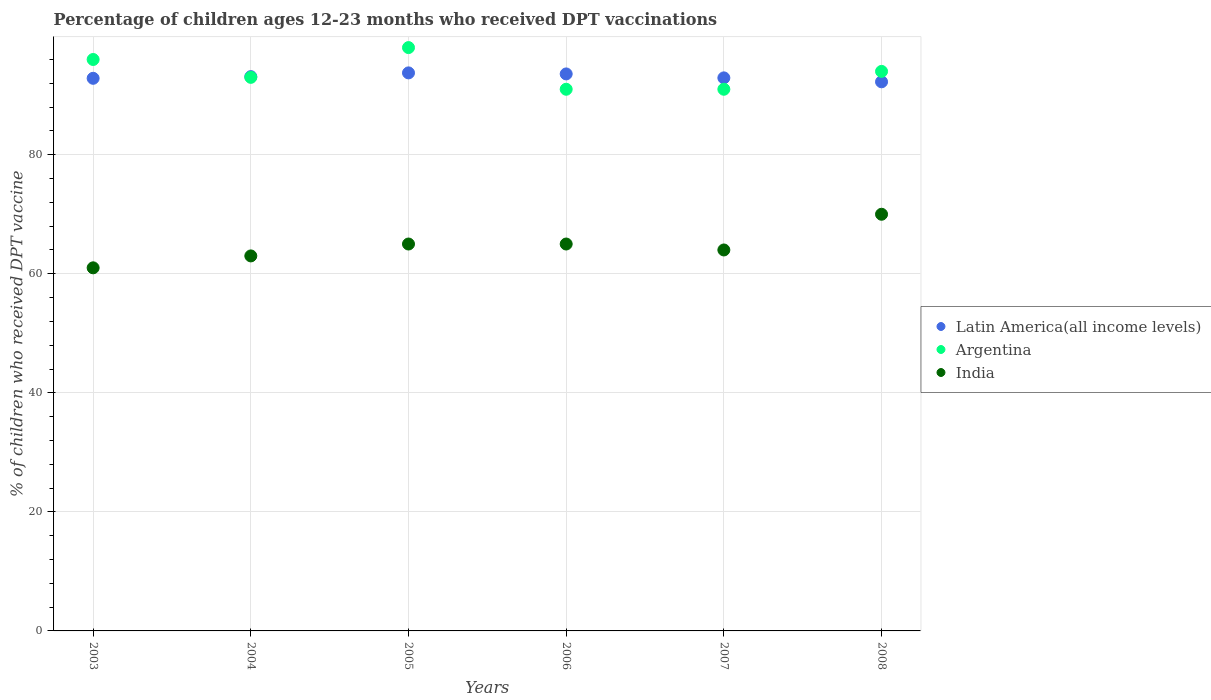What is the percentage of children who received DPT vaccination in India in 2005?
Provide a short and direct response. 65. Across all years, what is the maximum percentage of children who received DPT vaccination in Argentina?
Give a very brief answer. 98. Across all years, what is the minimum percentage of children who received DPT vaccination in Latin America(all income levels)?
Your answer should be compact. 92.25. What is the total percentage of children who received DPT vaccination in Argentina in the graph?
Your answer should be very brief. 563. What is the difference between the percentage of children who received DPT vaccination in Latin America(all income levels) in 2004 and that in 2008?
Your response must be concise. 0.87. What is the difference between the percentage of children who received DPT vaccination in India in 2006 and the percentage of children who received DPT vaccination in Argentina in 2003?
Ensure brevity in your answer.  -31. What is the average percentage of children who received DPT vaccination in Argentina per year?
Provide a short and direct response. 93.83. In the year 2007, what is the difference between the percentage of children who received DPT vaccination in Argentina and percentage of children who received DPT vaccination in Latin America(all income levels)?
Give a very brief answer. -1.91. In how many years, is the percentage of children who received DPT vaccination in India greater than 52 %?
Give a very brief answer. 6. What is the ratio of the percentage of children who received DPT vaccination in Latin America(all income levels) in 2003 to that in 2006?
Your answer should be compact. 0.99. Is the percentage of children who received DPT vaccination in Argentina in 2006 less than that in 2007?
Give a very brief answer. No. What is the difference between the highest and the second highest percentage of children who received DPT vaccination in Latin America(all income levels)?
Ensure brevity in your answer.  0.18. What is the difference between the highest and the lowest percentage of children who received DPT vaccination in Latin America(all income levels)?
Make the answer very short. 1.5. Is it the case that in every year, the sum of the percentage of children who received DPT vaccination in India and percentage of children who received DPT vaccination in Argentina  is greater than the percentage of children who received DPT vaccination in Latin America(all income levels)?
Keep it short and to the point. Yes. Does the percentage of children who received DPT vaccination in Argentina monotonically increase over the years?
Offer a terse response. No. Is the percentage of children who received DPT vaccination in India strictly greater than the percentage of children who received DPT vaccination in Argentina over the years?
Your answer should be compact. No. How many dotlines are there?
Provide a short and direct response. 3. How many years are there in the graph?
Your answer should be compact. 6. Are the values on the major ticks of Y-axis written in scientific E-notation?
Your response must be concise. No. Does the graph contain any zero values?
Give a very brief answer. No. Does the graph contain grids?
Your answer should be compact. Yes. Where does the legend appear in the graph?
Ensure brevity in your answer.  Center right. How are the legend labels stacked?
Make the answer very short. Vertical. What is the title of the graph?
Offer a terse response. Percentage of children ages 12-23 months who received DPT vaccinations. What is the label or title of the X-axis?
Your response must be concise. Years. What is the label or title of the Y-axis?
Keep it short and to the point. % of children who received DPT vaccine. What is the % of children who received DPT vaccine in Latin America(all income levels) in 2003?
Your answer should be very brief. 92.84. What is the % of children who received DPT vaccine of Argentina in 2003?
Keep it short and to the point. 96. What is the % of children who received DPT vaccine in Latin America(all income levels) in 2004?
Give a very brief answer. 93.12. What is the % of children who received DPT vaccine of Argentina in 2004?
Offer a very short reply. 93. What is the % of children who received DPT vaccine in Latin America(all income levels) in 2005?
Make the answer very short. 93.75. What is the % of children who received DPT vaccine in Argentina in 2005?
Your answer should be compact. 98. What is the % of children who received DPT vaccine in Latin America(all income levels) in 2006?
Offer a very short reply. 93.57. What is the % of children who received DPT vaccine of Argentina in 2006?
Make the answer very short. 91. What is the % of children who received DPT vaccine of India in 2006?
Provide a short and direct response. 65. What is the % of children who received DPT vaccine of Latin America(all income levels) in 2007?
Ensure brevity in your answer.  92.91. What is the % of children who received DPT vaccine in Argentina in 2007?
Provide a succinct answer. 91. What is the % of children who received DPT vaccine in Latin America(all income levels) in 2008?
Your response must be concise. 92.25. What is the % of children who received DPT vaccine of Argentina in 2008?
Your answer should be very brief. 94. What is the % of children who received DPT vaccine in India in 2008?
Offer a terse response. 70. Across all years, what is the maximum % of children who received DPT vaccine in Latin America(all income levels)?
Provide a succinct answer. 93.75. Across all years, what is the maximum % of children who received DPT vaccine in Argentina?
Your response must be concise. 98. Across all years, what is the minimum % of children who received DPT vaccine of Latin America(all income levels)?
Offer a terse response. 92.25. Across all years, what is the minimum % of children who received DPT vaccine of Argentina?
Keep it short and to the point. 91. Across all years, what is the minimum % of children who received DPT vaccine in India?
Keep it short and to the point. 61. What is the total % of children who received DPT vaccine in Latin America(all income levels) in the graph?
Make the answer very short. 558.45. What is the total % of children who received DPT vaccine in Argentina in the graph?
Ensure brevity in your answer.  563. What is the total % of children who received DPT vaccine in India in the graph?
Make the answer very short. 388. What is the difference between the % of children who received DPT vaccine in Latin America(all income levels) in 2003 and that in 2004?
Your response must be concise. -0.28. What is the difference between the % of children who received DPT vaccine in Latin America(all income levels) in 2003 and that in 2005?
Give a very brief answer. -0.91. What is the difference between the % of children who received DPT vaccine in Argentina in 2003 and that in 2005?
Your answer should be very brief. -2. What is the difference between the % of children who received DPT vaccine in Latin America(all income levels) in 2003 and that in 2006?
Provide a short and direct response. -0.74. What is the difference between the % of children who received DPT vaccine in Argentina in 2003 and that in 2006?
Give a very brief answer. 5. What is the difference between the % of children who received DPT vaccine in Latin America(all income levels) in 2003 and that in 2007?
Make the answer very short. -0.07. What is the difference between the % of children who received DPT vaccine of Argentina in 2003 and that in 2007?
Ensure brevity in your answer.  5. What is the difference between the % of children who received DPT vaccine of India in 2003 and that in 2007?
Your answer should be very brief. -3. What is the difference between the % of children who received DPT vaccine of Latin America(all income levels) in 2003 and that in 2008?
Offer a very short reply. 0.59. What is the difference between the % of children who received DPT vaccine of Latin America(all income levels) in 2004 and that in 2005?
Keep it short and to the point. -0.63. What is the difference between the % of children who received DPT vaccine of Argentina in 2004 and that in 2005?
Ensure brevity in your answer.  -5. What is the difference between the % of children who received DPT vaccine of India in 2004 and that in 2005?
Your answer should be very brief. -2. What is the difference between the % of children who received DPT vaccine of Latin America(all income levels) in 2004 and that in 2006?
Ensure brevity in your answer.  -0.45. What is the difference between the % of children who received DPT vaccine of Latin America(all income levels) in 2004 and that in 2007?
Ensure brevity in your answer.  0.21. What is the difference between the % of children who received DPT vaccine in Argentina in 2004 and that in 2007?
Your answer should be very brief. 2. What is the difference between the % of children who received DPT vaccine of India in 2004 and that in 2007?
Give a very brief answer. -1. What is the difference between the % of children who received DPT vaccine of Latin America(all income levels) in 2004 and that in 2008?
Ensure brevity in your answer.  0.87. What is the difference between the % of children who received DPT vaccine in Latin America(all income levels) in 2005 and that in 2006?
Make the answer very short. 0.18. What is the difference between the % of children who received DPT vaccine in India in 2005 and that in 2006?
Keep it short and to the point. 0. What is the difference between the % of children who received DPT vaccine in Latin America(all income levels) in 2005 and that in 2007?
Ensure brevity in your answer.  0.84. What is the difference between the % of children who received DPT vaccine of Argentina in 2005 and that in 2007?
Keep it short and to the point. 7. What is the difference between the % of children who received DPT vaccine of Latin America(all income levels) in 2005 and that in 2008?
Your answer should be compact. 1.5. What is the difference between the % of children who received DPT vaccine in Argentina in 2005 and that in 2008?
Your answer should be compact. 4. What is the difference between the % of children who received DPT vaccine of India in 2005 and that in 2008?
Provide a succinct answer. -5. What is the difference between the % of children who received DPT vaccine of Latin America(all income levels) in 2006 and that in 2007?
Give a very brief answer. 0.66. What is the difference between the % of children who received DPT vaccine of Argentina in 2006 and that in 2007?
Provide a succinct answer. 0. What is the difference between the % of children who received DPT vaccine in Latin America(all income levels) in 2006 and that in 2008?
Give a very brief answer. 1.32. What is the difference between the % of children who received DPT vaccine in India in 2006 and that in 2008?
Ensure brevity in your answer.  -5. What is the difference between the % of children who received DPT vaccine of Latin America(all income levels) in 2007 and that in 2008?
Keep it short and to the point. 0.66. What is the difference between the % of children who received DPT vaccine of Latin America(all income levels) in 2003 and the % of children who received DPT vaccine of Argentina in 2004?
Provide a succinct answer. -0.16. What is the difference between the % of children who received DPT vaccine of Latin America(all income levels) in 2003 and the % of children who received DPT vaccine of India in 2004?
Provide a succinct answer. 29.84. What is the difference between the % of children who received DPT vaccine of Argentina in 2003 and the % of children who received DPT vaccine of India in 2004?
Offer a terse response. 33. What is the difference between the % of children who received DPT vaccine in Latin America(all income levels) in 2003 and the % of children who received DPT vaccine in Argentina in 2005?
Your answer should be very brief. -5.16. What is the difference between the % of children who received DPT vaccine of Latin America(all income levels) in 2003 and the % of children who received DPT vaccine of India in 2005?
Provide a succinct answer. 27.84. What is the difference between the % of children who received DPT vaccine in Latin America(all income levels) in 2003 and the % of children who received DPT vaccine in Argentina in 2006?
Your answer should be compact. 1.84. What is the difference between the % of children who received DPT vaccine in Latin America(all income levels) in 2003 and the % of children who received DPT vaccine in India in 2006?
Offer a very short reply. 27.84. What is the difference between the % of children who received DPT vaccine of Latin America(all income levels) in 2003 and the % of children who received DPT vaccine of Argentina in 2007?
Make the answer very short. 1.84. What is the difference between the % of children who received DPT vaccine in Latin America(all income levels) in 2003 and the % of children who received DPT vaccine in India in 2007?
Your answer should be very brief. 28.84. What is the difference between the % of children who received DPT vaccine in Latin America(all income levels) in 2003 and the % of children who received DPT vaccine in Argentina in 2008?
Ensure brevity in your answer.  -1.16. What is the difference between the % of children who received DPT vaccine of Latin America(all income levels) in 2003 and the % of children who received DPT vaccine of India in 2008?
Your answer should be compact. 22.84. What is the difference between the % of children who received DPT vaccine of Argentina in 2003 and the % of children who received DPT vaccine of India in 2008?
Give a very brief answer. 26. What is the difference between the % of children who received DPT vaccine in Latin America(all income levels) in 2004 and the % of children who received DPT vaccine in Argentina in 2005?
Give a very brief answer. -4.88. What is the difference between the % of children who received DPT vaccine of Latin America(all income levels) in 2004 and the % of children who received DPT vaccine of India in 2005?
Your answer should be compact. 28.12. What is the difference between the % of children who received DPT vaccine of Argentina in 2004 and the % of children who received DPT vaccine of India in 2005?
Your answer should be compact. 28. What is the difference between the % of children who received DPT vaccine in Latin America(all income levels) in 2004 and the % of children who received DPT vaccine in Argentina in 2006?
Provide a succinct answer. 2.12. What is the difference between the % of children who received DPT vaccine of Latin America(all income levels) in 2004 and the % of children who received DPT vaccine of India in 2006?
Make the answer very short. 28.12. What is the difference between the % of children who received DPT vaccine of Latin America(all income levels) in 2004 and the % of children who received DPT vaccine of Argentina in 2007?
Offer a very short reply. 2.12. What is the difference between the % of children who received DPT vaccine in Latin America(all income levels) in 2004 and the % of children who received DPT vaccine in India in 2007?
Provide a short and direct response. 29.12. What is the difference between the % of children who received DPT vaccine in Argentina in 2004 and the % of children who received DPT vaccine in India in 2007?
Offer a terse response. 29. What is the difference between the % of children who received DPT vaccine in Latin America(all income levels) in 2004 and the % of children who received DPT vaccine in Argentina in 2008?
Offer a terse response. -0.88. What is the difference between the % of children who received DPT vaccine of Latin America(all income levels) in 2004 and the % of children who received DPT vaccine of India in 2008?
Your answer should be compact. 23.12. What is the difference between the % of children who received DPT vaccine of Latin America(all income levels) in 2005 and the % of children who received DPT vaccine of Argentina in 2006?
Ensure brevity in your answer.  2.75. What is the difference between the % of children who received DPT vaccine in Latin America(all income levels) in 2005 and the % of children who received DPT vaccine in India in 2006?
Provide a short and direct response. 28.75. What is the difference between the % of children who received DPT vaccine in Argentina in 2005 and the % of children who received DPT vaccine in India in 2006?
Keep it short and to the point. 33. What is the difference between the % of children who received DPT vaccine of Latin America(all income levels) in 2005 and the % of children who received DPT vaccine of Argentina in 2007?
Your response must be concise. 2.75. What is the difference between the % of children who received DPT vaccine in Latin America(all income levels) in 2005 and the % of children who received DPT vaccine in India in 2007?
Give a very brief answer. 29.75. What is the difference between the % of children who received DPT vaccine of Argentina in 2005 and the % of children who received DPT vaccine of India in 2007?
Ensure brevity in your answer.  34. What is the difference between the % of children who received DPT vaccine of Latin America(all income levels) in 2005 and the % of children who received DPT vaccine of Argentina in 2008?
Offer a terse response. -0.25. What is the difference between the % of children who received DPT vaccine in Latin America(all income levels) in 2005 and the % of children who received DPT vaccine in India in 2008?
Make the answer very short. 23.75. What is the difference between the % of children who received DPT vaccine of Latin America(all income levels) in 2006 and the % of children who received DPT vaccine of Argentina in 2007?
Make the answer very short. 2.57. What is the difference between the % of children who received DPT vaccine in Latin America(all income levels) in 2006 and the % of children who received DPT vaccine in India in 2007?
Provide a succinct answer. 29.57. What is the difference between the % of children who received DPT vaccine of Latin America(all income levels) in 2006 and the % of children who received DPT vaccine of Argentina in 2008?
Give a very brief answer. -0.43. What is the difference between the % of children who received DPT vaccine of Latin America(all income levels) in 2006 and the % of children who received DPT vaccine of India in 2008?
Offer a very short reply. 23.57. What is the difference between the % of children who received DPT vaccine in Latin America(all income levels) in 2007 and the % of children who received DPT vaccine in Argentina in 2008?
Your answer should be compact. -1.09. What is the difference between the % of children who received DPT vaccine of Latin America(all income levels) in 2007 and the % of children who received DPT vaccine of India in 2008?
Keep it short and to the point. 22.91. What is the average % of children who received DPT vaccine in Latin America(all income levels) per year?
Provide a short and direct response. 93.07. What is the average % of children who received DPT vaccine in Argentina per year?
Ensure brevity in your answer.  93.83. What is the average % of children who received DPT vaccine in India per year?
Keep it short and to the point. 64.67. In the year 2003, what is the difference between the % of children who received DPT vaccine of Latin America(all income levels) and % of children who received DPT vaccine of Argentina?
Your response must be concise. -3.16. In the year 2003, what is the difference between the % of children who received DPT vaccine of Latin America(all income levels) and % of children who received DPT vaccine of India?
Your response must be concise. 31.84. In the year 2003, what is the difference between the % of children who received DPT vaccine of Argentina and % of children who received DPT vaccine of India?
Offer a terse response. 35. In the year 2004, what is the difference between the % of children who received DPT vaccine in Latin America(all income levels) and % of children who received DPT vaccine in Argentina?
Your response must be concise. 0.12. In the year 2004, what is the difference between the % of children who received DPT vaccine of Latin America(all income levels) and % of children who received DPT vaccine of India?
Give a very brief answer. 30.12. In the year 2004, what is the difference between the % of children who received DPT vaccine in Argentina and % of children who received DPT vaccine in India?
Keep it short and to the point. 30. In the year 2005, what is the difference between the % of children who received DPT vaccine of Latin America(all income levels) and % of children who received DPT vaccine of Argentina?
Your answer should be very brief. -4.25. In the year 2005, what is the difference between the % of children who received DPT vaccine in Latin America(all income levels) and % of children who received DPT vaccine in India?
Your response must be concise. 28.75. In the year 2005, what is the difference between the % of children who received DPT vaccine of Argentina and % of children who received DPT vaccine of India?
Offer a terse response. 33. In the year 2006, what is the difference between the % of children who received DPT vaccine in Latin America(all income levels) and % of children who received DPT vaccine in Argentina?
Ensure brevity in your answer.  2.57. In the year 2006, what is the difference between the % of children who received DPT vaccine of Latin America(all income levels) and % of children who received DPT vaccine of India?
Keep it short and to the point. 28.57. In the year 2007, what is the difference between the % of children who received DPT vaccine in Latin America(all income levels) and % of children who received DPT vaccine in Argentina?
Your answer should be compact. 1.91. In the year 2007, what is the difference between the % of children who received DPT vaccine of Latin America(all income levels) and % of children who received DPT vaccine of India?
Your response must be concise. 28.91. In the year 2008, what is the difference between the % of children who received DPT vaccine of Latin America(all income levels) and % of children who received DPT vaccine of Argentina?
Make the answer very short. -1.75. In the year 2008, what is the difference between the % of children who received DPT vaccine in Latin America(all income levels) and % of children who received DPT vaccine in India?
Provide a succinct answer. 22.25. What is the ratio of the % of children who received DPT vaccine in Latin America(all income levels) in 2003 to that in 2004?
Offer a terse response. 1. What is the ratio of the % of children who received DPT vaccine of Argentina in 2003 to that in 2004?
Provide a short and direct response. 1.03. What is the ratio of the % of children who received DPT vaccine in India in 2003 to that in 2004?
Keep it short and to the point. 0.97. What is the ratio of the % of children who received DPT vaccine of Latin America(all income levels) in 2003 to that in 2005?
Your answer should be very brief. 0.99. What is the ratio of the % of children who received DPT vaccine of Argentina in 2003 to that in 2005?
Provide a short and direct response. 0.98. What is the ratio of the % of children who received DPT vaccine in India in 2003 to that in 2005?
Offer a terse response. 0.94. What is the ratio of the % of children who received DPT vaccine of Argentina in 2003 to that in 2006?
Ensure brevity in your answer.  1.05. What is the ratio of the % of children who received DPT vaccine of India in 2003 to that in 2006?
Provide a succinct answer. 0.94. What is the ratio of the % of children who received DPT vaccine in Latin America(all income levels) in 2003 to that in 2007?
Offer a very short reply. 1. What is the ratio of the % of children who received DPT vaccine of Argentina in 2003 to that in 2007?
Your answer should be compact. 1.05. What is the ratio of the % of children who received DPT vaccine in India in 2003 to that in 2007?
Give a very brief answer. 0.95. What is the ratio of the % of children who received DPT vaccine of Latin America(all income levels) in 2003 to that in 2008?
Your answer should be very brief. 1.01. What is the ratio of the % of children who received DPT vaccine in Argentina in 2003 to that in 2008?
Make the answer very short. 1.02. What is the ratio of the % of children who received DPT vaccine of India in 2003 to that in 2008?
Your response must be concise. 0.87. What is the ratio of the % of children who received DPT vaccine in Argentina in 2004 to that in 2005?
Your answer should be compact. 0.95. What is the ratio of the % of children who received DPT vaccine of India in 2004 to that in 2005?
Provide a succinct answer. 0.97. What is the ratio of the % of children who received DPT vaccine of Latin America(all income levels) in 2004 to that in 2006?
Your answer should be compact. 1. What is the ratio of the % of children who received DPT vaccine of Argentina in 2004 to that in 2006?
Your answer should be very brief. 1.02. What is the ratio of the % of children who received DPT vaccine in India in 2004 to that in 2006?
Ensure brevity in your answer.  0.97. What is the ratio of the % of children who received DPT vaccine in Argentina in 2004 to that in 2007?
Provide a succinct answer. 1.02. What is the ratio of the % of children who received DPT vaccine of India in 2004 to that in 2007?
Offer a terse response. 0.98. What is the ratio of the % of children who received DPT vaccine in Latin America(all income levels) in 2004 to that in 2008?
Your answer should be compact. 1.01. What is the ratio of the % of children who received DPT vaccine in Argentina in 2004 to that in 2008?
Provide a succinct answer. 0.99. What is the ratio of the % of children who received DPT vaccine of India in 2004 to that in 2008?
Keep it short and to the point. 0.9. What is the ratio of the % of children who received DPT vaccine in Latin America(all income levels) in 2005 to that in 2006?
Make the answer very short. 1. What is the ratio of the % of children who received DPT vaccine of Argentina in 2005 to that in 2006?
Offer a very short reply. 1.08. What is the ratio of the % of children who received DPT vaccine of India in 2005 to that in 2006?
Your answer should be very brief. 1. What is the ratio of the % of children who received DPT vaccine of India in 2005 to that in 2007?
Offer a very short reply. 1.02. What is the ratio of the % of children who received DPT vaccine in Latin America(all income levels) in 2005 to that in 2008?
Ensure brevity in your answer.  1.02. What is the ratio of the % of children who received DPT vaccine of Argentina in 2005 to that in 2008?
Make the answer very short. 1.04. What is the ratio of the % of children who received DPT vaccine in India in 2005 to that in 2008?
Provide a short and direct response. 0.93. What is the ratio of the % of children who received DPT vaccine of Latin America(all income levels) in 2006 to that in 2007?
Keep it short and to the point. 1.01. What is the ratio of the % of children who received DPT vaccine of India in 2006 to that in 2007?
Provide a short and direct response. 1.02. What is the ratio of the % of children who received DPT vaccine of Latin America(all income levels) in 2006 to that in 2008?
Provide a short and direct response. 1.01. What is the ratio of the % of children who received DPT vaccine of Argentina in 2006 to that in 2008?
Ensure brevity in your answer.  0.97. What is the ratio of the % of children who received DPT vaccine of Argentina in 2007 to that in 2008?
Provide a short and direct response. 0.97. What is the ratio of the % of children who received DPT vaccine of India in 2007 to that in 2008?
Offer a very short reply. 0.91. What is the difference between the highest and the second highest % of children who received DPT vaccine of Latin America(all income levels)?
Offer a very short reply. 0.18. What is the difference between the highest and the second highest % of children who received DPT vaccine of India?
Provide a succinct answer. 5. What is the difference between the highest and the lowest % of children who received DPT vaccine in Latin America(all income levels)?
Provide a short and direct response. 1.5. What is the difference between the highest and the lowest % of children who received DPT vaccine of Argentina?
Keep it short and to the point. 7. 